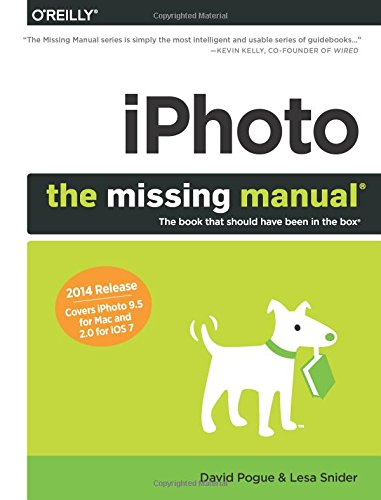Who wrote this book? David Pogue, along with Lesa Snider, authored this book titled 'iPhoto: The Missing Manual'. Together, they provide comprehensive guidance on using the iPhoto software. 